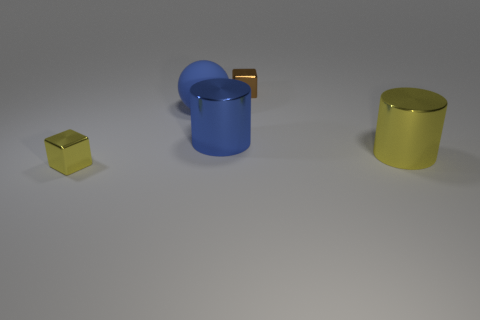Add 5 blue metal cylinders. How many objects exist? 10 Subtract 1 blocks. How many blocks are left? 1 Subtract all spheres. How many objects are left? 4 Subtract all red cylinders. Subtract all yellow blocks. How many cylinders are left? 2 Subtract all tiny yellow things. Subtract all yellow metal cubes. How many objects are left? 3 Add 2 big metal things. How many big metal things are left? 4 Add 5 yellow blocks. How many yellow blocks exist? 6 Subtract 0 gray cubes. How many objects are left? 5 